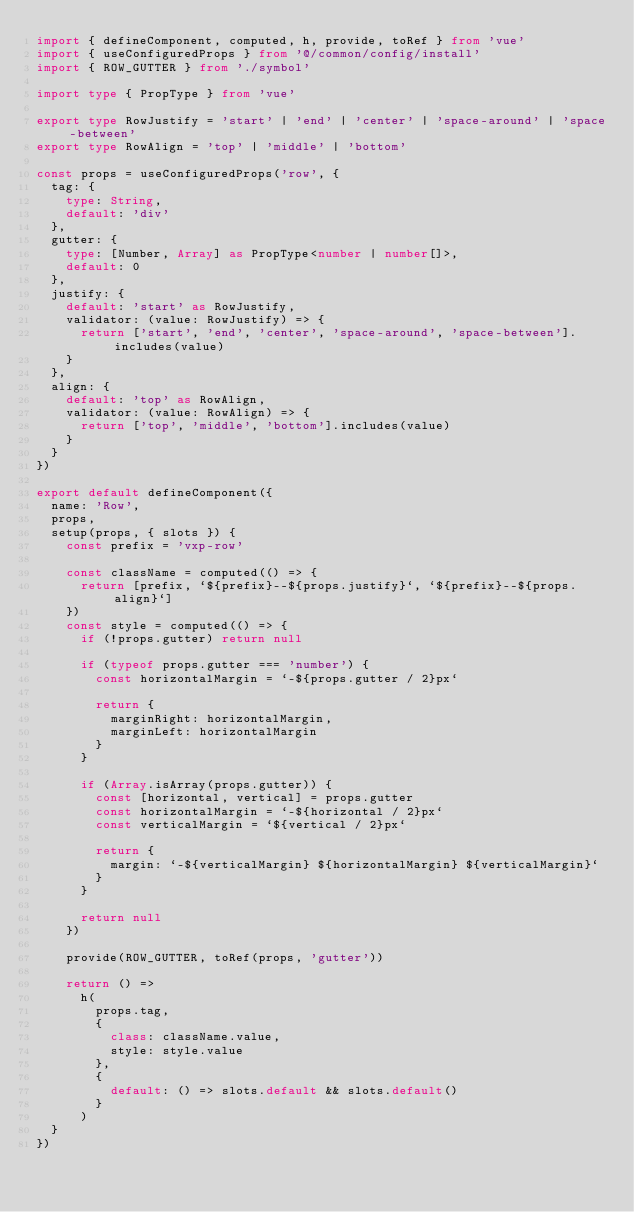<code> <loc_0><loc_0><loc_500><loc_500><_TypeScript_>import { defineComponent, computed, h, provide, toRef } from 'vue'
import { useConfiguredProps } from '@/common/config/install'
import { ROW_GUTTER } from './symbol'

import type { PropType } from 'vue'

export type RowJustify = 'start' | 'end' | 'center' | 'space-around' | 'space-between'
export type RowAlign = 'top' | 'middle' | 'bottom'

const props = useConfiguredProps('row', {
  tag: {
    type: String,
    default: 'div'
  },
  gutter: {
    type: [Number, Array] as PropType<number | number[]>,
    default: 0
  },
  justify: {
    default: 'start' as RowJustify,
    validator: (value: RowJustify) => {
      return ['start', 'end', 'center', 'space-around', 'space-between'].includes(value)
    }
  },
  align: {
    default: 'top' as RowAlign,
    validator: (value: RowAlign) => {
      return ['top', 'middle', 'bottom'].includes(value)
    }
  }
})

export default defineComponent({
  name: 'Row',
  props,
  setup(props, { slots }) {
    const prefix = 'vxp-row'

    const className = computed(() => {
      return [prefix, `${prefix}--${props.justify}`, `${prefix}--${props.align}`]
    })
    const style = computed(() => {
      if (!props.gutter) return null

      if (typeof props.gutter === 'number') {
        const horizontalMargin = `-${props.gutter / 2}px`

        return {
          marginRight: horizontalMargin,
          marginLeft: horizontalMargin
        }
      }

      if (Array.isArray(props.gutter)) {
        const [horizontal, vertical] = props.gutter
        const horizontalMargin = `-${horizontal / 2}px`
        const verticalMargin = `${vertical / 2}px`

        return {
          margin: `-${verticalMargin} ${horizontalMargin} ${verticalMargin}`
        }
      }

      return null
    })

    provide(ROW_GUTTER, toRef(props, 'gutter'))

    return () =>
      h(
        props.tag,
        {
          class: className.value,
          style: style.value
        },
        {
          default: () => slots.default && slots.default()
        }
      )
  }
})
</code> 